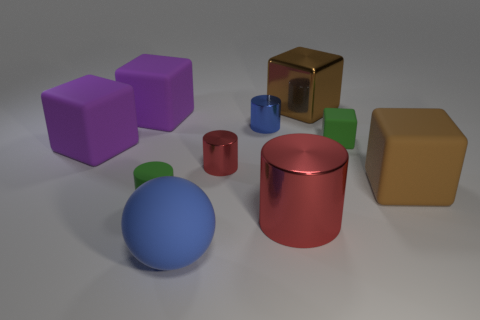Subtract all cylinders. How many objects are left? 6 Subtract all tiny rubber blocks. How many blocks are left? 4 Subtract 0 red blocks. How many objects are left? 10 How many red cylinders must be subtracted to get 1 red cylinders? 1 Subtract 3 cubes. How many cubes are left? 2 Subtract all blue cylinders. Subtract all gray balls. How many cylinders are left? 3 Subtract all red cubes. How many red cylinders are left? 2 Subtract all tiny blue things. Subtract all tiny red matte blocks. How many objects are left? 9 Add 9 blue metallic cylinders. How many blue metallic cylinders are left? 10 Add 4 small purple matte cylinders. How many small purple matte cylinders exist? 4 